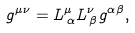Convert formula to latex. <formula><loc_0><loc_0><loc_500><loc_500>g ^ { \mu \nu } = L ^ { \mu } _ { \, \alpha } L ^ { \nu } _ { \, \beta } g ^ { \alpha \beta } ,</formula> 